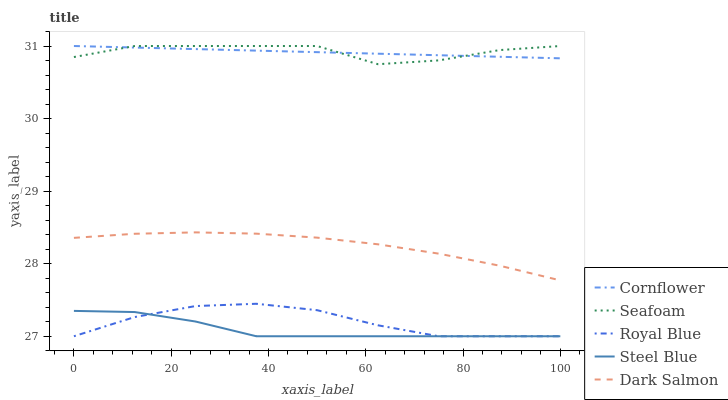Does Steel Blue have the minimum area under the curve?
Answer yes or no. Yes. Does Seafoam have the maximum area under the curve?
Answer yes or no. Yes. Does Dark Salmon have the minimum area under the curve?
Answer yes or no. No. Does Dark Salmon have the maximum area under the curve?
Answer yes or no. No. Is Cornflower the smoothest?
Answer yes or no. Yes. Is Seafoam the roughest?
Answer yes or no. Yes. Is Steel Blue the smoothest?
Answer yes or no. No. Is Steel Blue the roughest?
Answer yes or no. No. Does Steel Blue have the lowest value?
Answer yes or no. Yes. Does Dark Salmon have the lowest value?
Answer yes or no. No. Does Seafoam have the highest value?
Answer yes or no. Yes. Does Dark Salmon have the highest value?
Answer yes or no. No. Is Royal Blue less than Seafoam?
Answer yes or no. Yes. Is Seafoam greater than Dark Salmon?
Answer yes or no. Yes. Does Royal Blue intersect Steel Blue?
Answer yes or no. Yes. Is Royal Blue less than Steel Blue?
Answer yes or no. No. Is Royal Blue greater than Steel Blue?
Answer yes or no. No. Does Royal Blue intersect Seafoam?
Answer yes or no. No. 